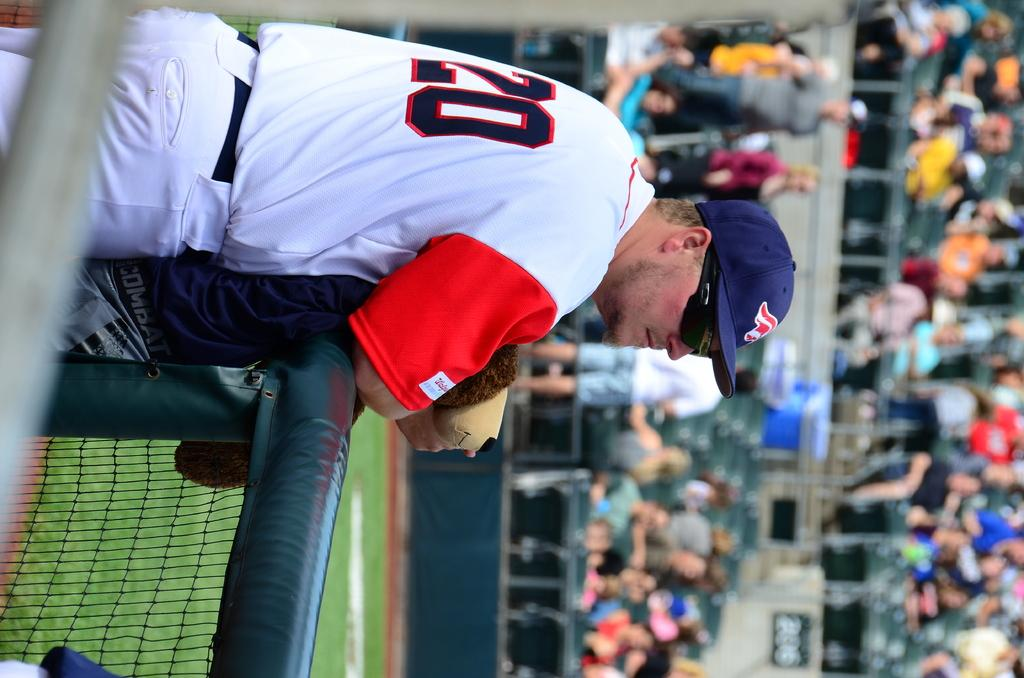What can be seen in the image involving multiple individuals? There is a group of people in the image. What type of barrier is present in the image? There is a fence in the image. What type of vegetation is visible in the image? There is grass in the image. Can you describe the attire of one of the individuals in the image? A man is wearing a blue color cap, goggles, and a white color t-shirt. How many letters can be seen on the man's t-shirt in the image? There is no information about letters on the man's t-shirt in the image. Can you describe the toes of the people in the image? There is no information about the toes of the people in the image. 